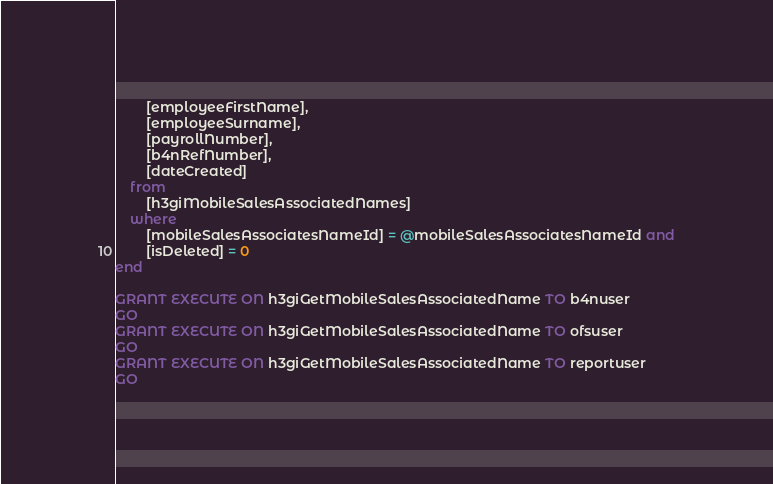Convert code to text. <code><loc_0><loc_0><loc_500><loc_500><_SQL_>		[employeeFirstName],
		[employeeSurname],
		[payrollNumber],
		[b4nRefNumber],
		[dateCreated]
	from
		[h3giMobileSalesAssociatedNames]
	where
		[mobileSalesAssociatesNameId] = @mobileSalesAssociatesNameId and
		[isDeleted] = 0
end

GRANT EXECUTE ON h3giGetMobileSalesAssociatedName TO b4nuser
GO
GRANT EXECUTE ON h3giGetMobileSalesAssociatedName TO ofsuser
GO
GRANT EXECUTE ON h3giGetMobileSalesAssociatedName TO reportuser
GO
</code> 